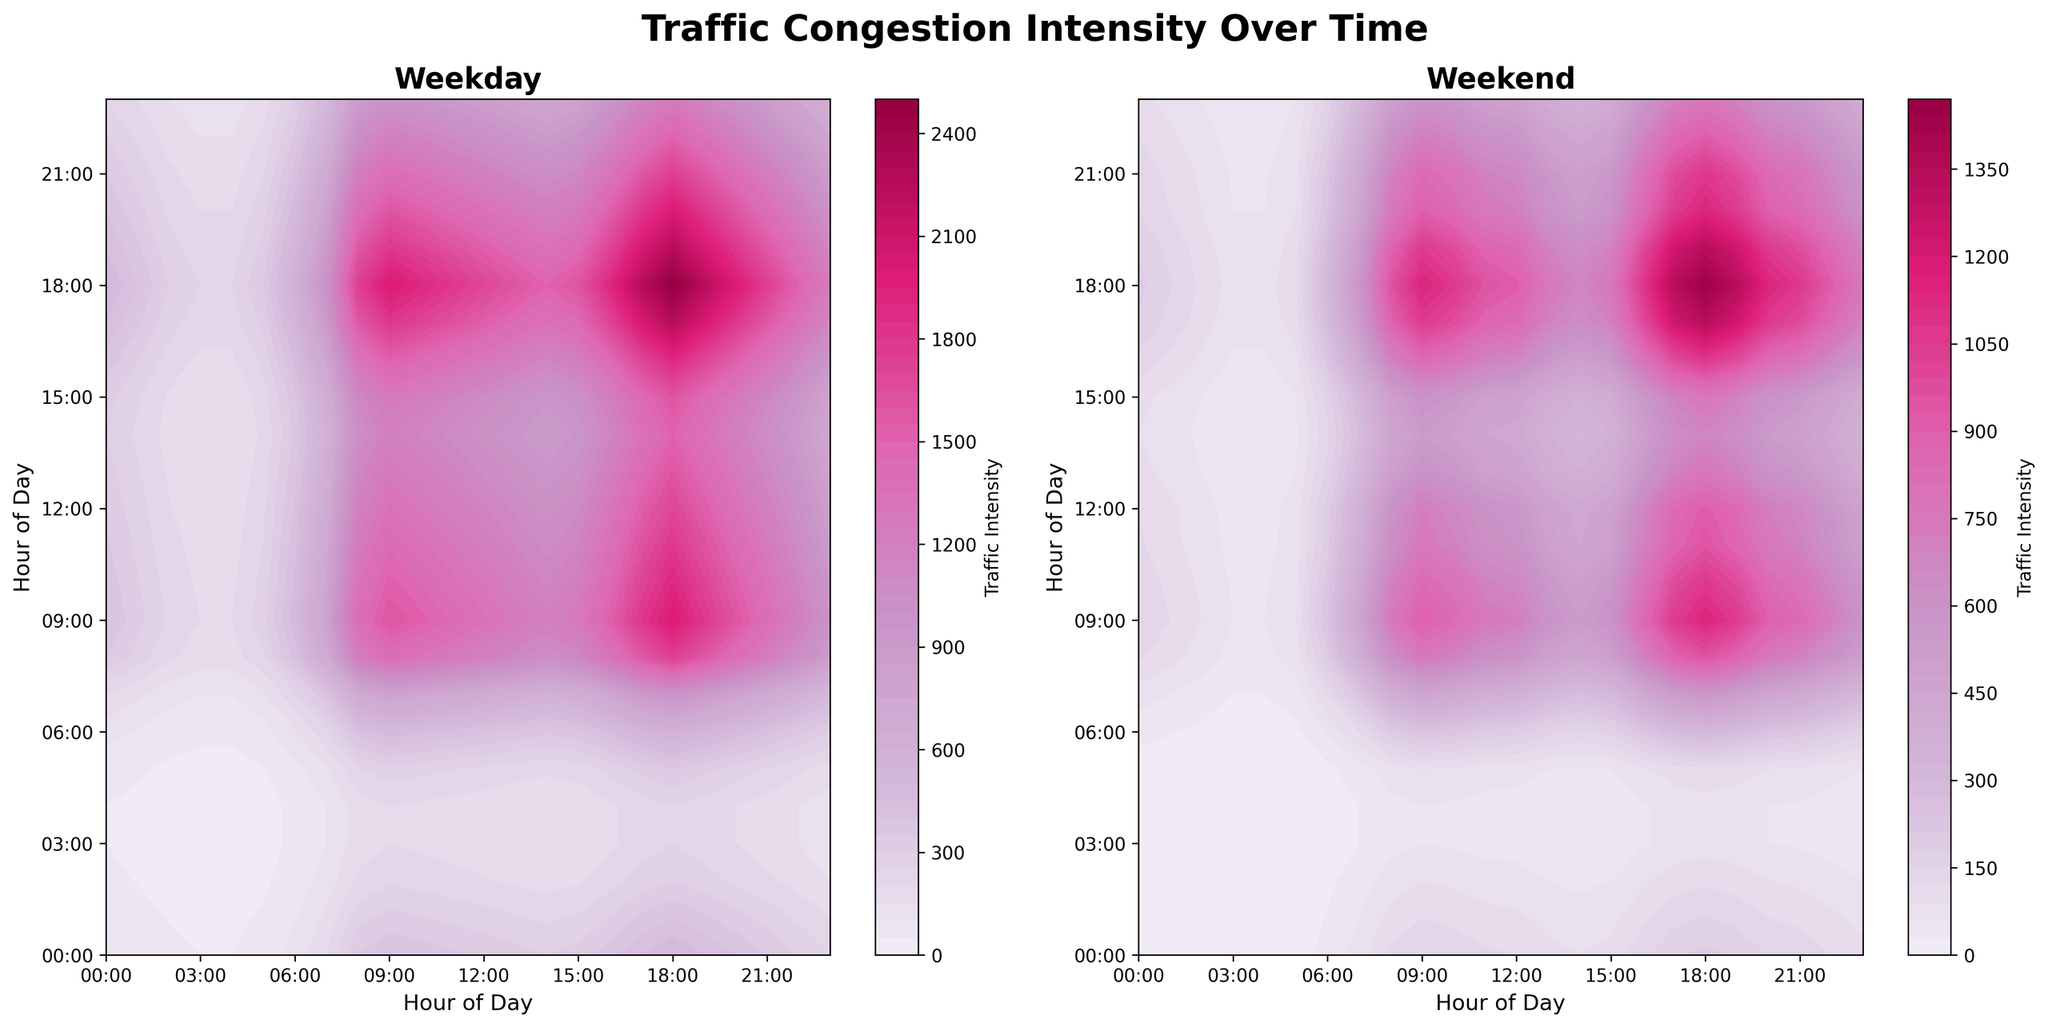What is the main title of the plot? The main title is typically located at the top center of the figure. It usually summarizes the overall content. Here, it reads "Traffic Congestion Intensity Over Time."
Answer: Traffic Congestion Intensity Over Time How many subplots are there? The figure contains one main figure divided into two subplots for comparison. Visually, we can identify them as the weekday and weekend subplots side by side.
Answer: 2 At what time does the weekday traffic intensity peak? By inspecting the contour plot on the left (weekday), the highest traffic intensity appears around 18:00, as indicated by the darkest color band.
Answer: 18:00 Which day type has generally higher traffic congestion during the morning peak hours? By comparing the morning peak hours (e.g., 7:00 to 9:00) in both subplots, the weekday plot shows darker colors indicating a higher intensity compared to the weekend plot.
Answer: Weekday What is the traffic intensity at 15:00 on weekends? Locate 15:00 on the x or y-axis in the weekend subplot and reference the intensity level using the color bar. The color around this time corresponds to a lighter color, representing a lower intensity.
Answer: 20 How does the traffic intensity at 12:00 compare between weekdays and weekends? Locate 12:00 on both subplots and compare the colors. The weekday subplot shows a darker color than the weekend subplot, indicating higher intensity on weekdays.
Answer: Weekday is higher What is the traffic intensity trend from 20:00 to 23:00 on weekdays? Observe the progression of colors from 20:00 to 23:00 on the weekday subplot. The intensity color decreases from a dark shade to a lighter one, indicating a reduction in traffic congestion over time.
Answer: Decreasing What time period shows the highest traffic intensity on weekends? Inspect the weekend subplot to find the darkest color band, which represents the highest intensity. It appears to be between 17:00 to 19:00.
Answer: 17:00 to 19:00 How does traffic congestion at 07:00 differ between weekdays and weekends? At 07:00, the weekday subplot shows much darker colors (higher intensity) compared to the same time on weekends. This indicates significantly higher congestion on weekdays.
Answer: Weekday is much higher What pattern is observed during early mornings (00:00 - 06:00) on both days? Both subplots show significantly lighter colors during the early morning hours, indicating much lower traffic congestion.
Answer: Low congestion on both days 